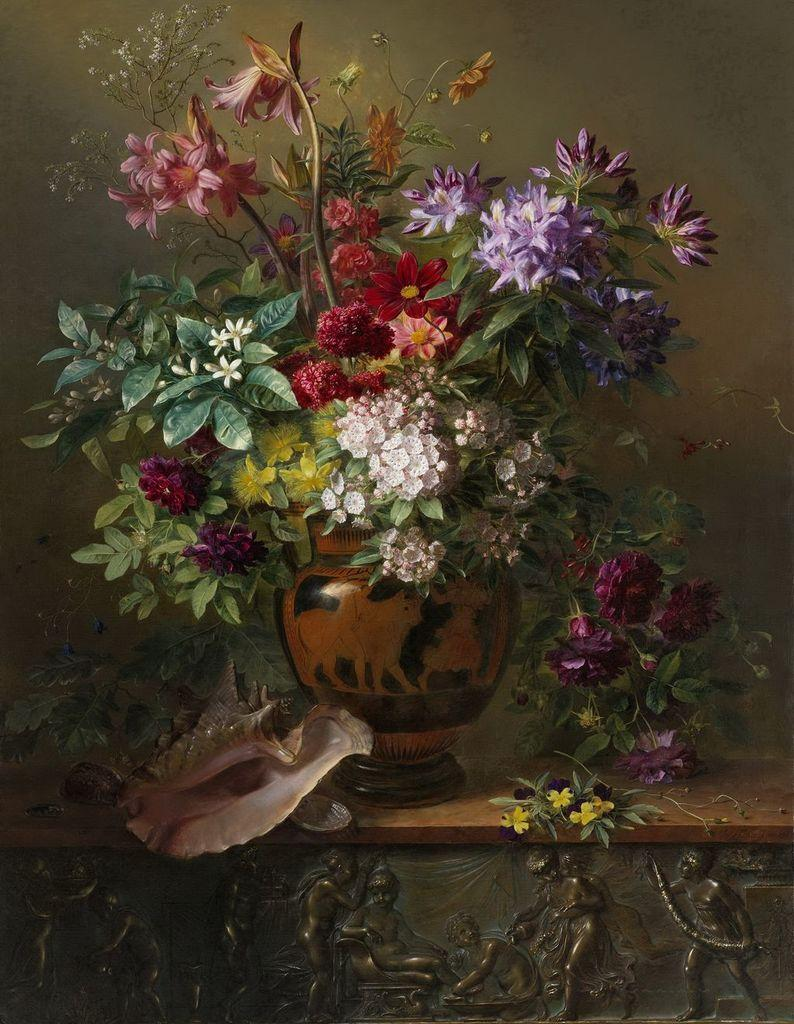What can be seen in the image that has been carved? There are carvings in the image. What type of plants are in the image? There are plants with flowers in a pot in the image. What other objects are present in the image? There are some objects in the image. What can be seen in the background of the image? There is a wall visible in the background of the image. How many rings does the parent wear in the image? There is no parent or rings present in the image. What type of bean is growing in the pot with the flowers? There are no beans present in the image; it features plants with flowers in a pot. 